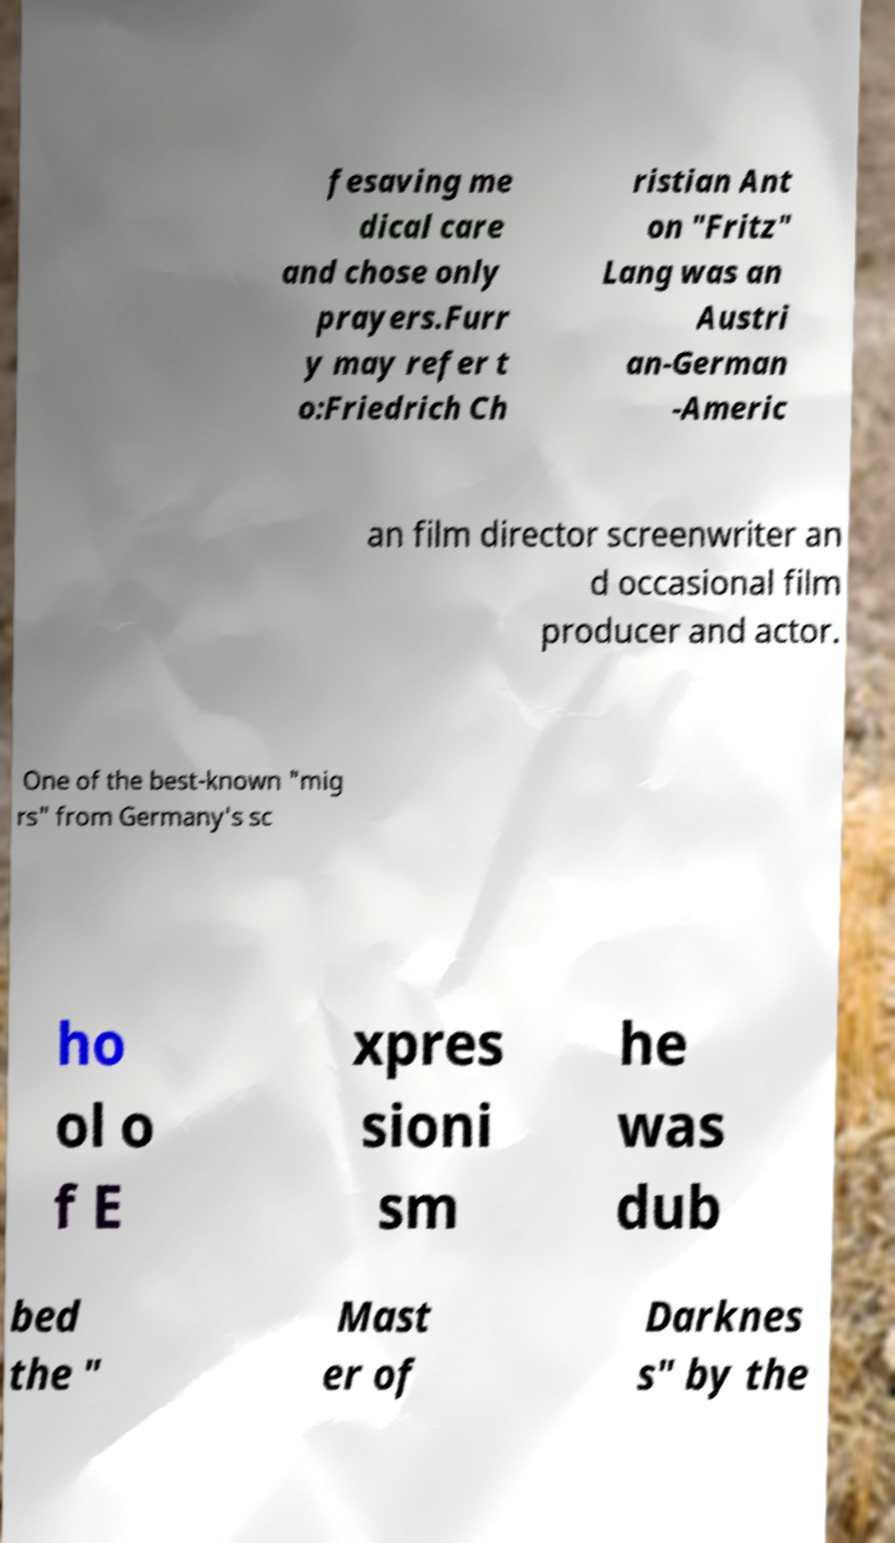What messages or text are displayed in this image? I need them in a readable, typed format. fesaving me dical care and chose only prayers.Furr y may refer t o:Friedrich Ch ristian Ant on "Fritz" Lang was an Austri an-German -Americ an film director screenwriter an d occasional film producer and actor. One of the best-known "mig rs" from Germany's sc ho ol o f E xpres sioni sm he was dub bed the " Mast er of Darknes s" by the 